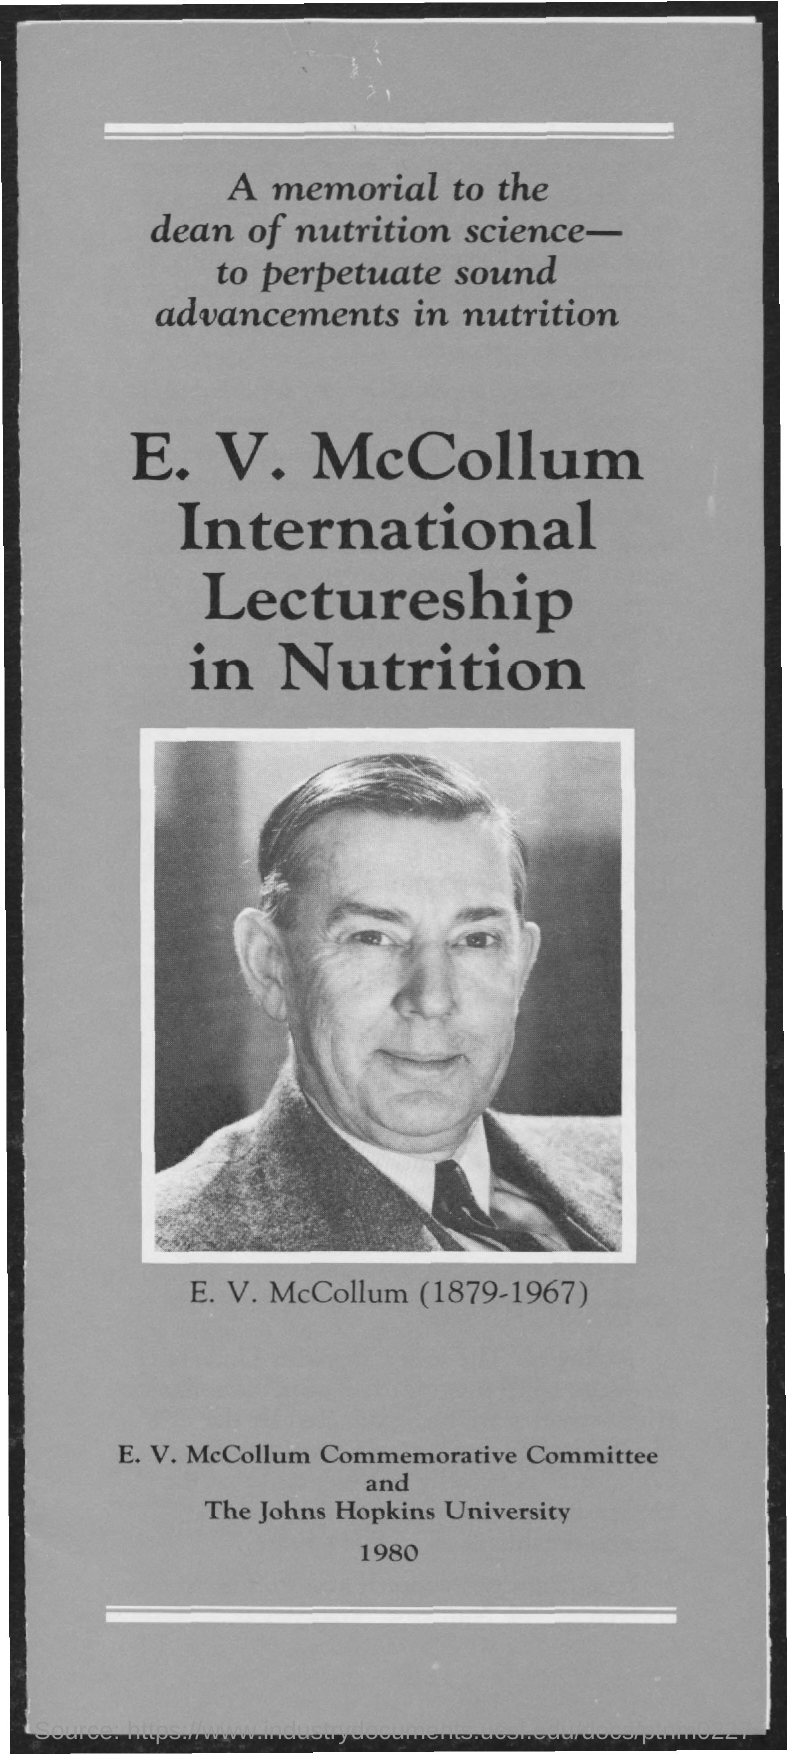Outline some significant characteristics in this image. The name of the university mentioned in the given form is the Johns Hopkins University. 